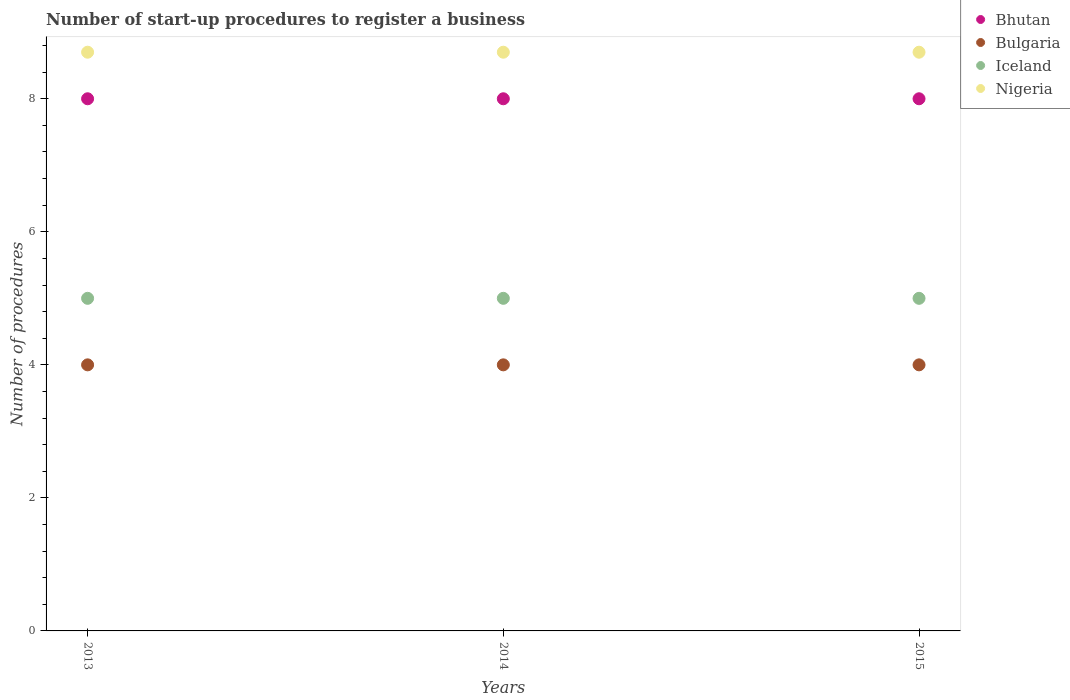How many different coloured dotlines are there?
Provide a succinct answer. 4. Is the number of dotlines equal to the number of legend labels?
Your response must be concise. Yes. What is the number of procedures required to register a business in Iceland in 2015?
Provide a short and direct response. 5. Across all years, what is the maximum number of procedures required to register a business in Iceland?
Offer a very short reply. 5. Across all years, what is the minimum number of procedures required to register a business in Bulgaria?
Make the answer very short. 4. In which year was the number of procedures required to register a business in Iceland minimum?
Offer a very short reply. 2013. What is the total number of procedures required to register a business in Bulgaria in the graph?
Give a very brief answer. 12. What is the difference between the number of procedures required to register a business in Nigeria in 2013 and that in 2014?
Offer a very short reply. 0. What is the difference between the number of procedures required to register a business in Bulgaria in 2013 and the number of procedures required to register a business in Nigeria in 2014?
Ensure brevity in your answer.  -4.7. What is the average number of procedures required to register a business in Bhutan per year?
Your response must be concise. 8. In the year 2014, what is the difference between the number of procedures required to register a business in Bulgaria and number of procedures required to register a business in Iceland?
Provide a short and direct response. -1. In how many years, is the number of procedures required to register a business in Bhutan greater than 3.6?
Ensure brevity in your answer.  3. What is the ratio of the number of procedures required to register a business in Nigeria in 2014 to that in 2015?
Your answer should be compact. 1. Is the number of procedures required to register a business in Iceland in 2013 less than that in 2014?
Keep it short and to the point. No. What is the difference between the highest and the lowest number of procedures required to register a business in Bhutan?
Make the answer very short. 0. In how many years, is the number of procedures required to register a business in Bhutan greater than the average number of procedures required to register a business in Bhutan taken over all years?
Give a very brief answer. 0. Is the sum of the number of procedures required to register a business in Iceland in 2013 and 2014 greater than the maximum number of procedures required to register a business in Nigeria across all years?
Your answer should be very brief. Yes. Is it the case that in every year, the sum of the number of procedures required to register a business in Iceland and number of procedures required to register a business in Nigeria  is greater than the sum of number of procedures required to register a business in Bhutan and number of procedures required to register a business in Bulgaria?
Give a very brief answer. Yes. How many dotlines are there?
Provide a succinct answer. 4. What is the difference between two consecutive major ticks on the Y-axis?
Offer a very short reply. 2. Does the graph contain any zero values?
Offer a terse response. No. Does the graph contain grids?
Make the answer very short. No. Where does the legend appear in the graph?
Offer a terse response. Top right. How many legend labels are there?
Offer a very short reply. 4. How are the legend labels stacked?
Offer a terse response. Vertical. What is the title of the graph?
Your answer should be very brief. Number of start-up procedures to register a business. Does "Indonesia" appear as one of the legend labels in the graph?
Your answer should be compact. No. What is the label or title of the Y-axis?
Offer a very short reply. Number of procedures. What is the Number of procedures of Iceland in 2013?
Your answer should be compact. 5. What is the Number of procedures of Bulgaria in 2014?
Keep it short and to the point. 4. What is the Number of procedures of Iceland in 2014?
Keep it short and to the point. 5. What is the Number of procedures of Nigeria in 2014?
Keep it short and to the point. 8.7. Across all years, what is the maximum Number of procedures in Bhutan?
Keep it short and to the point. 8. Across all years, what is the minimum Number of procedures in Bhutan?
Offer a very short reply. 8. Across all years, what is the minimum Number of procedures in Bulgaria?
Your response must be concise. 4. Across all years, what is the minimum Number of procedures in Iceland?
Ensure brevity in your answer.  5. Across all years, what is the minimum Number of procedures of Nigeria?
Offer a very short reply. 8.7. What is the total Number of procedures of Iceland in the graph?
Give a very brief answer. 15. What is the total Number of procedures in Nigeria in the graph?
Provide a short and direct response. 26.1. What is the difference between the Number of procedures of Bhutan in 2013 and that in 2014?
Offer a terse response. 0. What is the difference between the Number of procedures in Bulgaria in 2013 and that in 2014?
Make the answer very short. 0. What is the difference between the Number of procedures in Iceland in 2013 and that in 2014?
Provide a succinct answer. 0. What is the difference between the Number of procedures of Nigeria in 2013 and that in 2014?
Give a very brief answer. 0. What is the difference between the Number of procedures in Bulgaria in 2013 and that in 2015?
Ensure brevity in your answer.  0. What is the difference between the Number of procedures of Iceland in 2013 and that in 2015?
Keep it short and to the point. 0. What is the difference between the Number of procedures of Bulgaria in 2014 and that in 2015?
Your response must be concise. 0. What is the difference between the Number of procedures in Iceland in 2014 and that in 2015?
Offer a very short reply. 0. What is the difference between the Number of procedures in Nigeria in 2014 and that in 2015?
Your answer should be compact. 0. What is the difference between the Number of procedures of Bhutan in 2013 and the Number of procedures of Bulgaria in 2014?
Provide a short and direct response. 4. What is the difference between the Number of procedures of Bulgaria in 2013 and the Number of procedures of Iceland in 2014?
Offer a very short reply. -1. What is the difference between the Number of procedures in Bhutan in 2013 and the Number of procedures in Iceland in 2015?
Ensure brevity in your answer.  3. What is the difference between the Number of procedures of Bulgaria in 2013 and the Number of procedures of Iceland in 2015?
Your response must be concise. -1. What is the difference between the Number of procedures in Bulgaria in 2013 and the Number of procedures in Nigeria in 2015?
Your response must be concise. -4.7. What is the difference between the Number of procedures of Iceland in 2013 and the Number of procedures of Nigeria in 2015?
Make the answer very short. -3.7. What is the difference between the Number of procedures of Bhutan in 2014 and the Number of procedures of Bulgaria in 2015?
Your answer should be very brief. 4. What is the difference between the Number of procedures of Bhutan in 2014 and the Number of procedures of Iceland in 2015?
Ensure brevity in your answer.  3. What is the difference between the Number of procedures of Bulgaria in 2014 and the Number of procedures of Iceland in 2015?
Provide a short and direct response. -1. What is the difference between the Number of procedures of Bulgaria in 2014 and the Number of procedures of Nigeria in 2015?
Your answer should be very brief. -4.7. What is the difference between the Number of procedures of Iceland in 2014 and the Number of procedures of Nigeria in 2015?
Give a very brief answer. -3.7. What is the average Number of procedures of Bhutan per year?
Your answer should be compact. 8. What is the average Number of procedures of Nigeria per year?
Your answer should be compact. 8.7. In the year 2013, what is the difference between the Number of procedures in Bhutan and Number of procedures in Nigeria?
Offer a terse response. -0.7. In the year 2013, what is the difference between the Number of procedures of Bulgaria and Number of procedures of Iceland?
Your answer should be very brief. -1. In the year 2013, what is the difference between the Number of procedures of Bulgaria and Number of procedures of Nigeria?
Ensure brevity in your answer.  -4.7. In the year 2013, what is the difference between the Number of procedures in Iceland and Number of procedures in Nigeria?
Your answer should be very brief. -3.7. In the year 2014, what is the difference between the Number of procedures in Bhutan and Number of procedures in Iceland?
Provide a short and direct response. 3. In the year 2014, what is the difference between the Number of procedures of Bulgaria and Number of procedures of Iceland?
Your answer should be very brief. -1. In the year 2015, what is the difference between the Number of procedures of Bhutan and Number of procedures of Bulgaria?
Your answer should be very brief. 4. In the year 2015, what is the difference between the Number of procedures of Bulgaria and Number of procedures of Iceland?
Provide a succinct answer. -1. In the year 2015, what is the difference between the Number of procedures in Iceland and Number of procedures in Nigeria?
Provide a short and direct response. -3.7. What is the ratio of the Number of procedures of Bulgaria in 2013 to that in 2015?
Give a very brief answer. 1. What is the ratio of the Number of procedures in Bhutan in 2014 to that in 2015?
Provide a short and direct response. 1. What is the ratio of the Number of procedures in Bulgaria in 2014 to that in 2015?
Offer a very short reply. 1. What is the ratio of the Number of procedures in Iceland in 2014 to that in 2015?
Make the answer very short. 1. What is the difference between the highest and the second highest Number of procedures of Bulgaria?
Your response must be concise. 0. What is the difference between the highest and the second highest Number of procedures in Iceland?
Make the answer very short. 0. What is the difference between the highest and the second highest Number of procedures of Nigeria?
Keep it short and to the point. 0. What is the difference between the highest and the lowest Number of procedures in Iceland?
Make the answer very short. 0. 